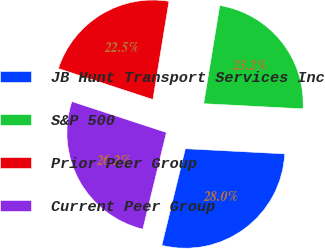Convert chart to OTSL. <chart><loc_0><loc_0><loc_500><loc_500><pie_chart><fcel>JB Hunt Transport Services Inc<fcel>S&P 500<fcel>Prior Peer Group<fcel>Current Peer Group<nl><fcel>27.98%<fcel>23.24%<fcel>22.54%<fcel>26.23%<nl></chart> 